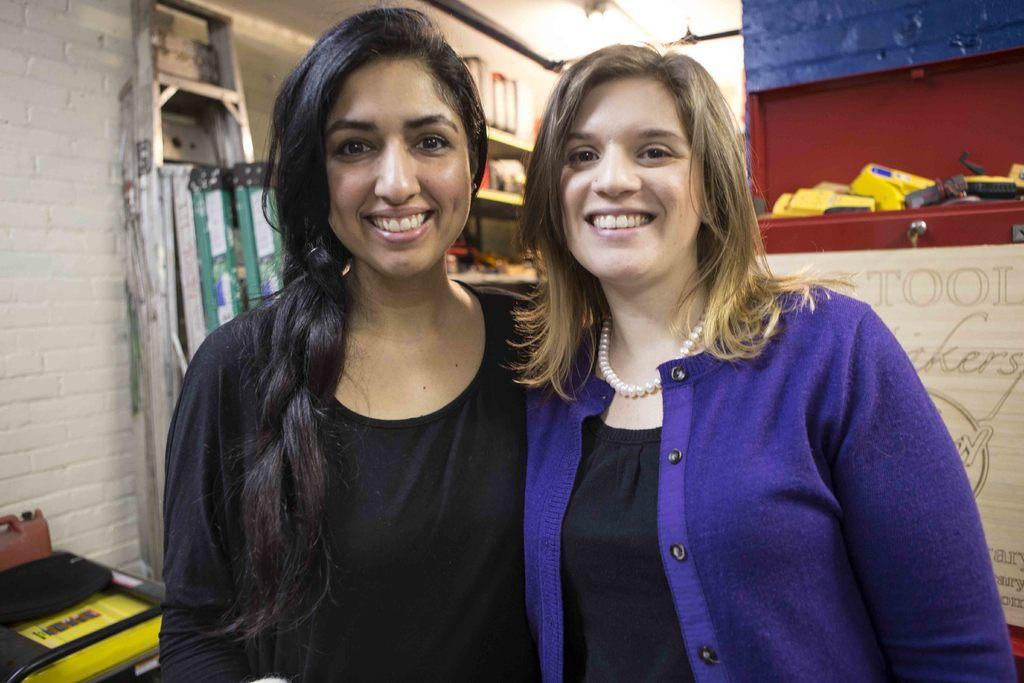How many people are in the image? There are two women in the image. What expression do the women have? The women are smiling. What can be seen in the background of the image? There are ladders, a wall, and some objects in the background of the image. What type of kitten is the women discussing in the image? There is no kitten present in the image, and the women are not discussing any kittens. What business idea are the women sharing in the image? There is no indication in the image that the women are discussing a business idea or any ideas at all. 